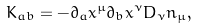Convert formula to latex. <formula><loc_0><loc_0><loc_500><loc_500>K _ { a b } = - \partial _ { a } x ^ { \mu } \partial _ { b } x ^ { \nu } D _ { \nu } n _ { \mu } ,</formula> 